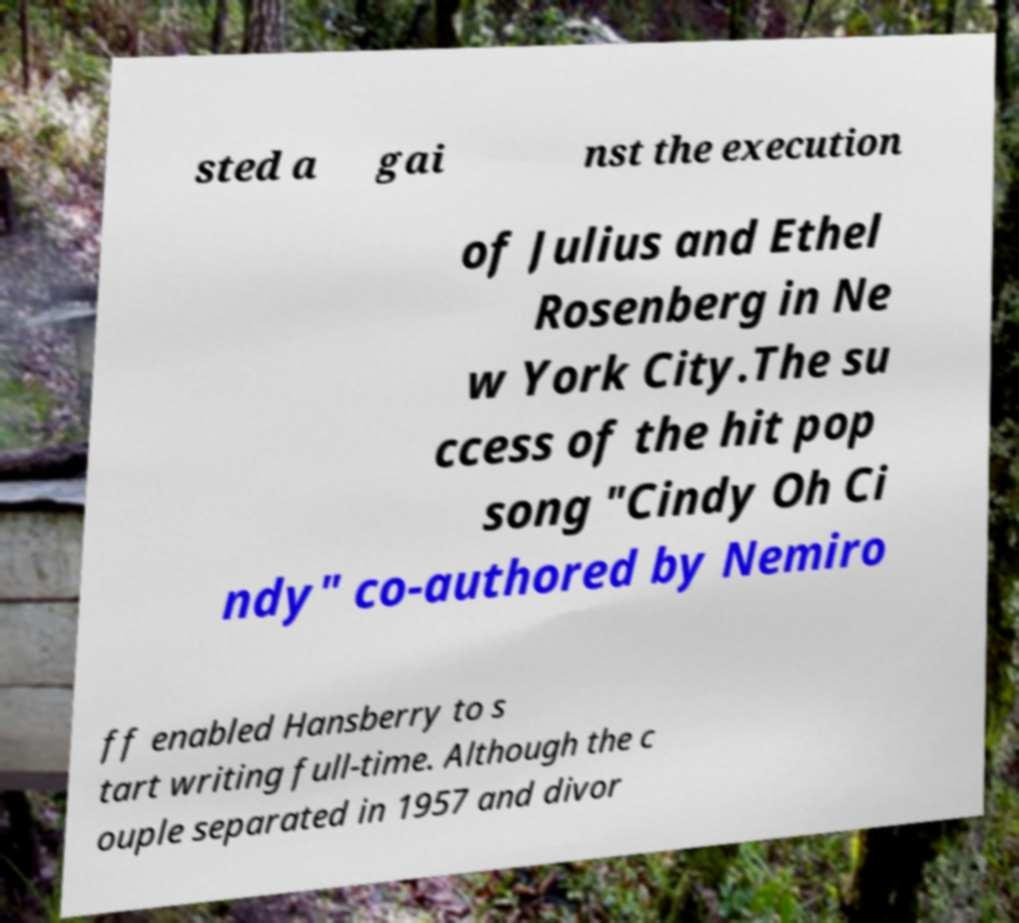For documentation purposes, I need the text within this image transcribed. Could you provide that? sted a gai nst the execution of Julius and Ethel Rosenberg in Ne w York City.The su ccess of the hit pop song "Cindy Oh Ci ndy" co-authored by Nemiro ff enabled Hansberry to s tart writing full-time. Although the c ouple separated in 1957 and divor 